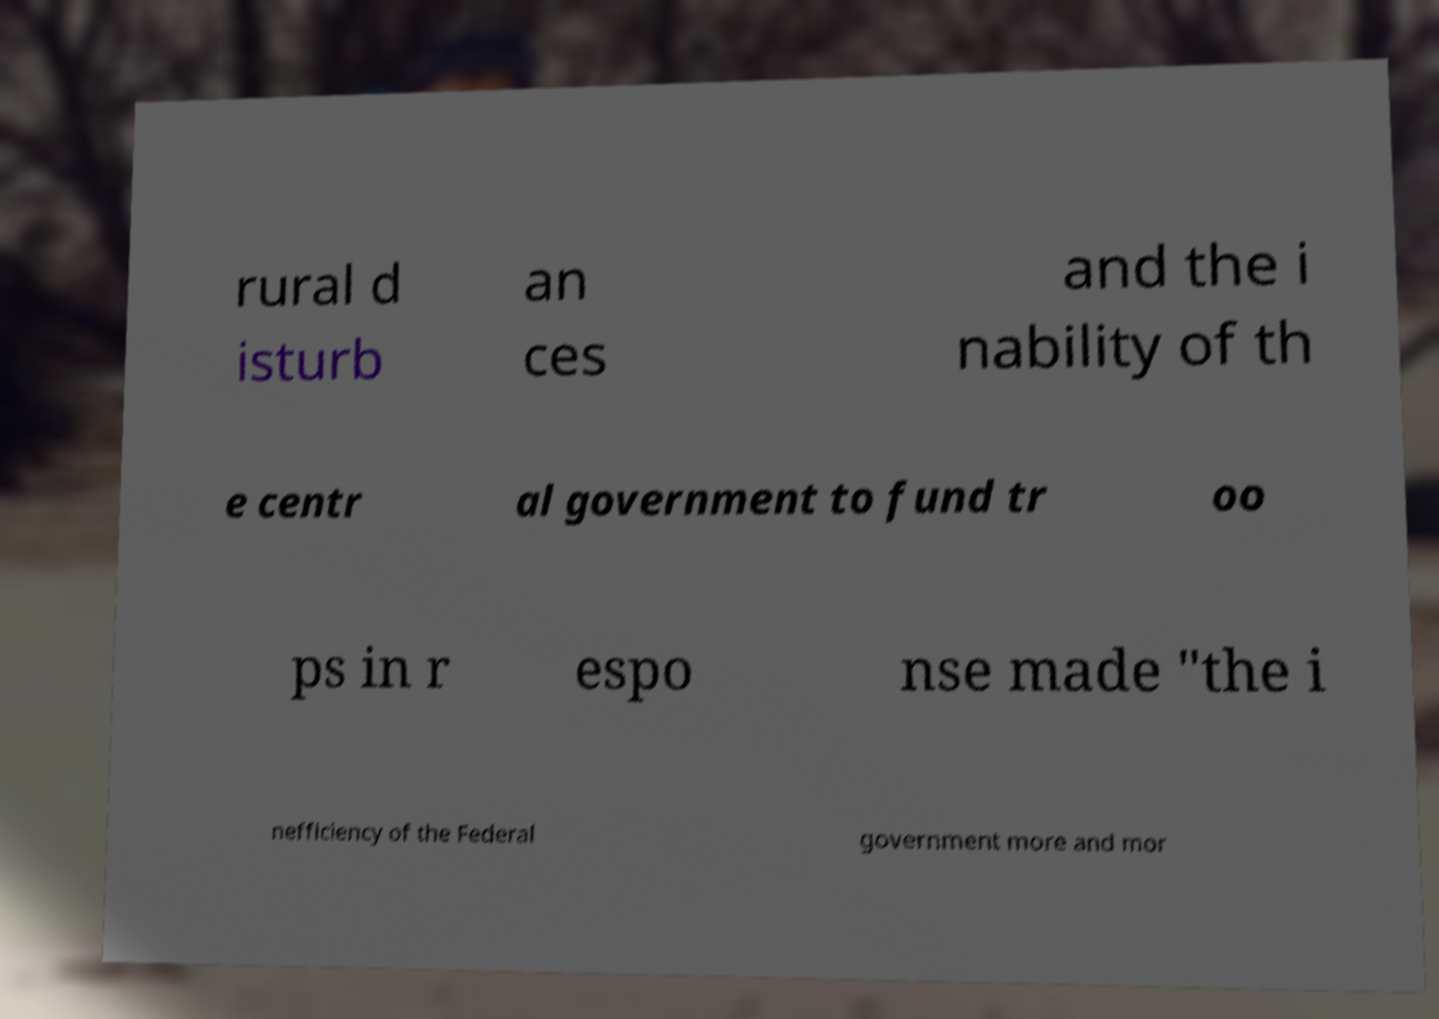I need the written content from this picture converted into text. Can you do that? rural d isturb an ces and the i nability of th e centr al government to fund tr oo ps in r espo nse made "the i nefficiency of the Federal government more and mor 